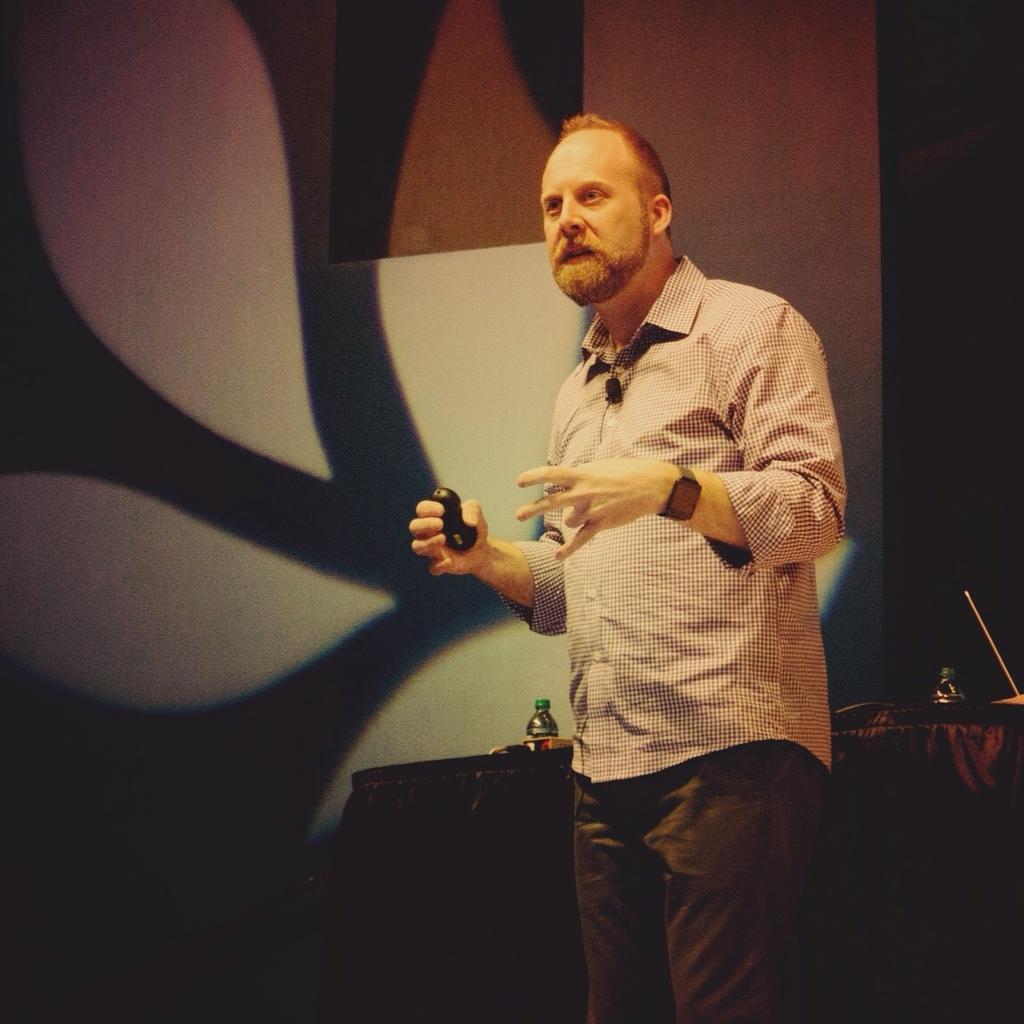Describe this image in one or two sentences. In the picture we can see a man standing and talking something doing actions with the hand and behind him we can see the table with black cloth on it with two water bottles and some things are placed and in the background we can see the wall with a designed light focus on it. 